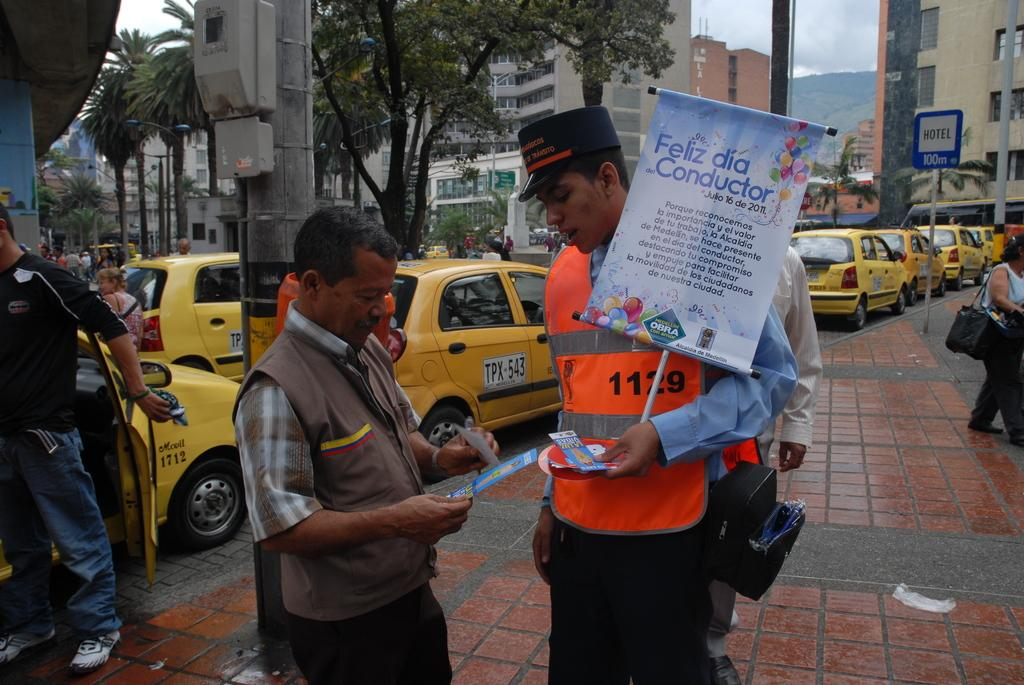<image>
Write a terse but informative summary of the picture. a person walking with a sign that has the word feliz on it 